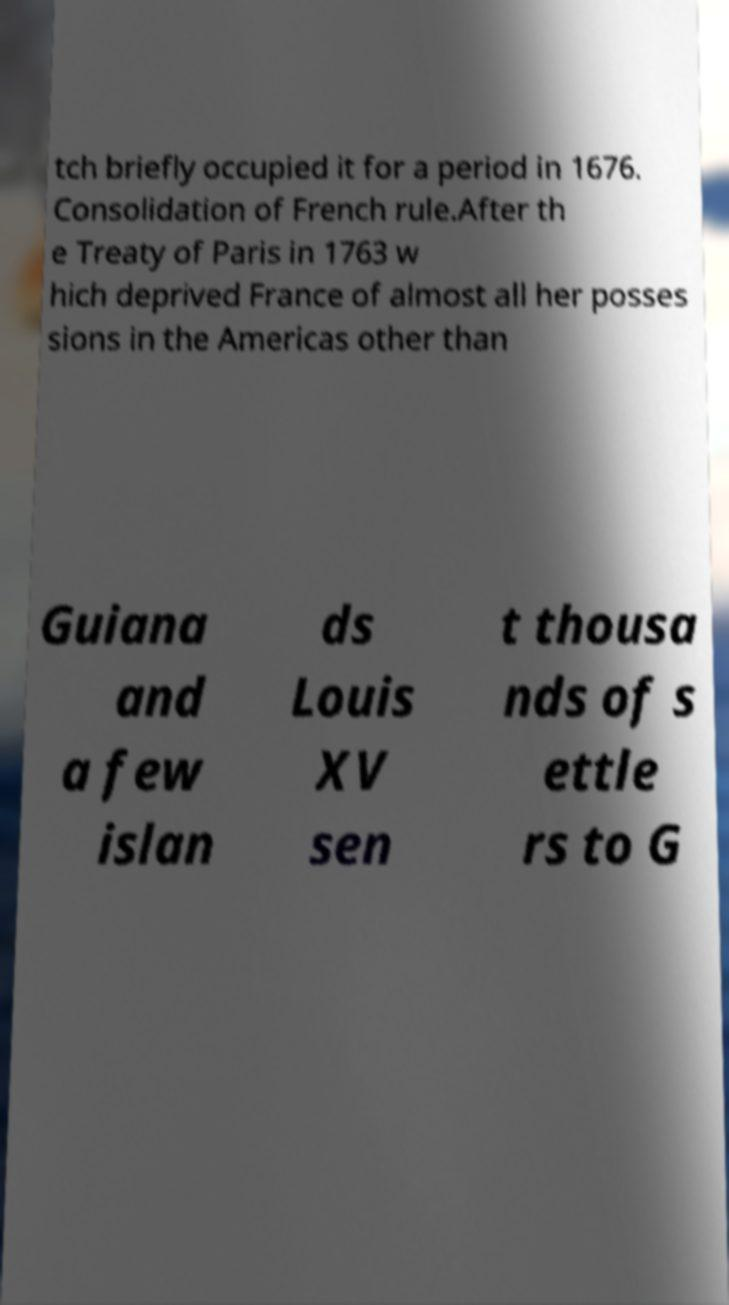What messages or text are displayed in this image? I need them in a readable, typed format. tch briefly occupied it for a period in 1676. Consolidation of French rule.After th e Treaty of Paris in 1763 w hich deprived France of almost all her posses sions in the Americas other than Guiana and a few islan ds Louis XV sen t thousa nds of s ettle rs to G 